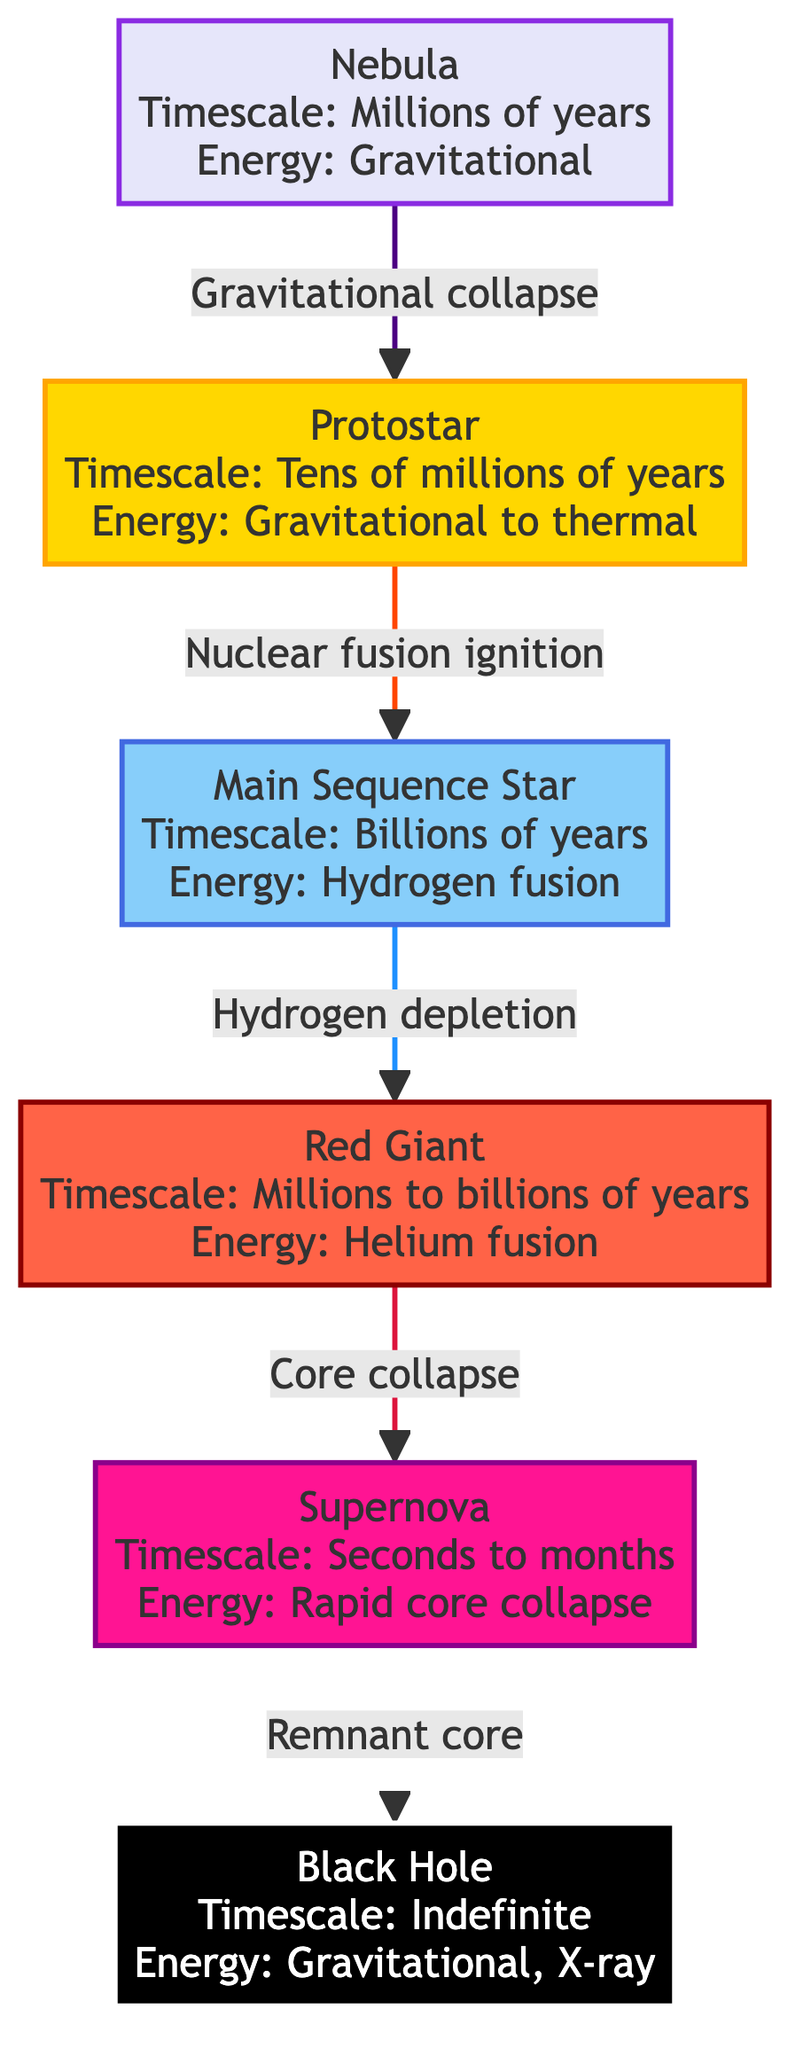What is the timescale for a nebula? The diagram indicates that the timescale for a nebula is "Millions of years." This information is displayed directly next to the "Nebula" node.
Answer: Millions of years What type of fusion occurs in the main sequence star? According to the diagram, the energy output of a main sequence star comes from "Hydrogen fusion," which is specified in the node for the main sequence star.
Answer: Hydrogen fusion What energy output is associated with the black hole? The black hole node specifies that its energy output is "Gravitational, X-ray." This information can be found directly adjacent to the black hole node in the diagram.
Answer: Gravitational, X-ray What process transitions a protostar to a main sequence star? The diagram shows an arrow from the protostar to the main sequence star labeled "Nuclear fusion ignition," indicating that this is the process responsible for that transition.
Answer: Nuclear fusion ignition How many main phases are there from nebula to black hole? By counting the nodes in the diagram from the nebula to the black hole, we find there are a total of five phases: Nebula, Protostar, Main Sequence Star, Red Giant, Supernova, and Black Hole.
Answer: Five What event leads to the supernova phase? The diagram states that the transition from the red giant to a supernova occurs through "Core collapse," which is indicated by the arrow connecting these two phases.
Answer: Core collapse What is the timescale of the supernova phase? The diagram specifies the timescale of the supernova phase as "Seconds to months," which directly appears next to the corresponding node in the diagram.
Answer: Seconds to months Which phase has the longest timescale? The main sequence star is highlighted in the diagram with a timescale of "Billions of years," which is longer than the timescales of the other phases.
Answer: Billions of years What processes are involved in energy output for the red giant phase? The red giant phase has an energy output associated with "Helium fusion," as stated in the diagram near the red giant node, highlighting this specific energy generation process.
Answer: Helium fusion 